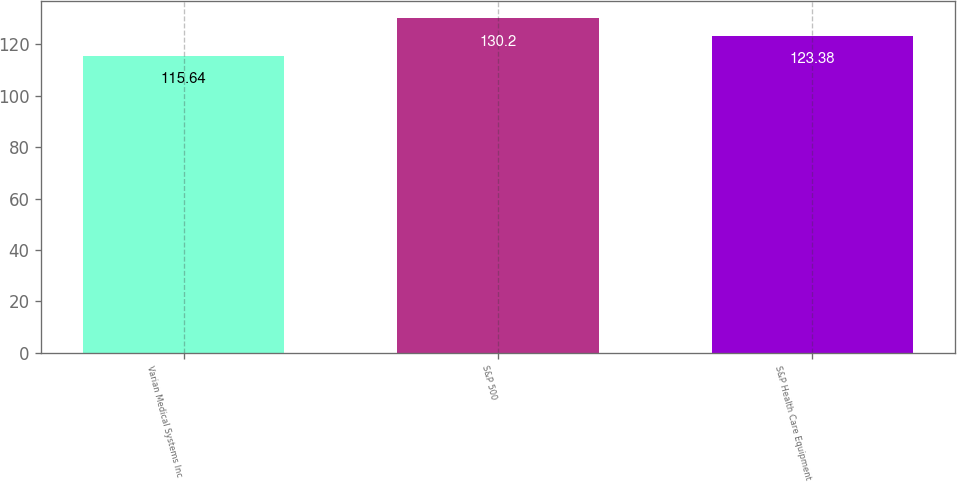Convert chart. <chart><loc_0><loc_0><loc_500><loc_500><bar_chart><fcel>Varian Medical Systems Inc<fcel>S&P 500<fcel>S&P Health Care Equipment<nl><fcel>115.64<fcel>130.2<fcel>123.38<nl></chart> 